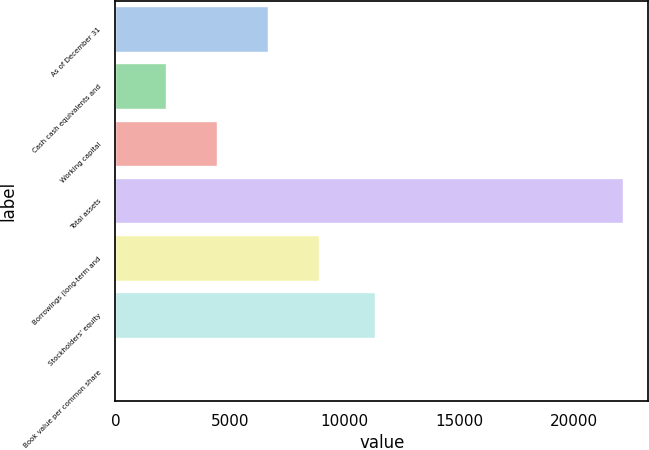<chart> <loc_0><loc_0><loc_500><loc_500><bar_chart><fcel>As of December 31<fcel>Cash cash equivalents and<fcel>Working capital<fcel>Total assets<fcel>Borrowings (long-term and<fcel>Stockholders' equity<fcel>Book value per common share<nl><fcel>6643.61<fcel>2219.49<fcel>4431.55<fcel>22128<fcel>8855.67<fcel>11296<fcel>7.43<nl></chart> 